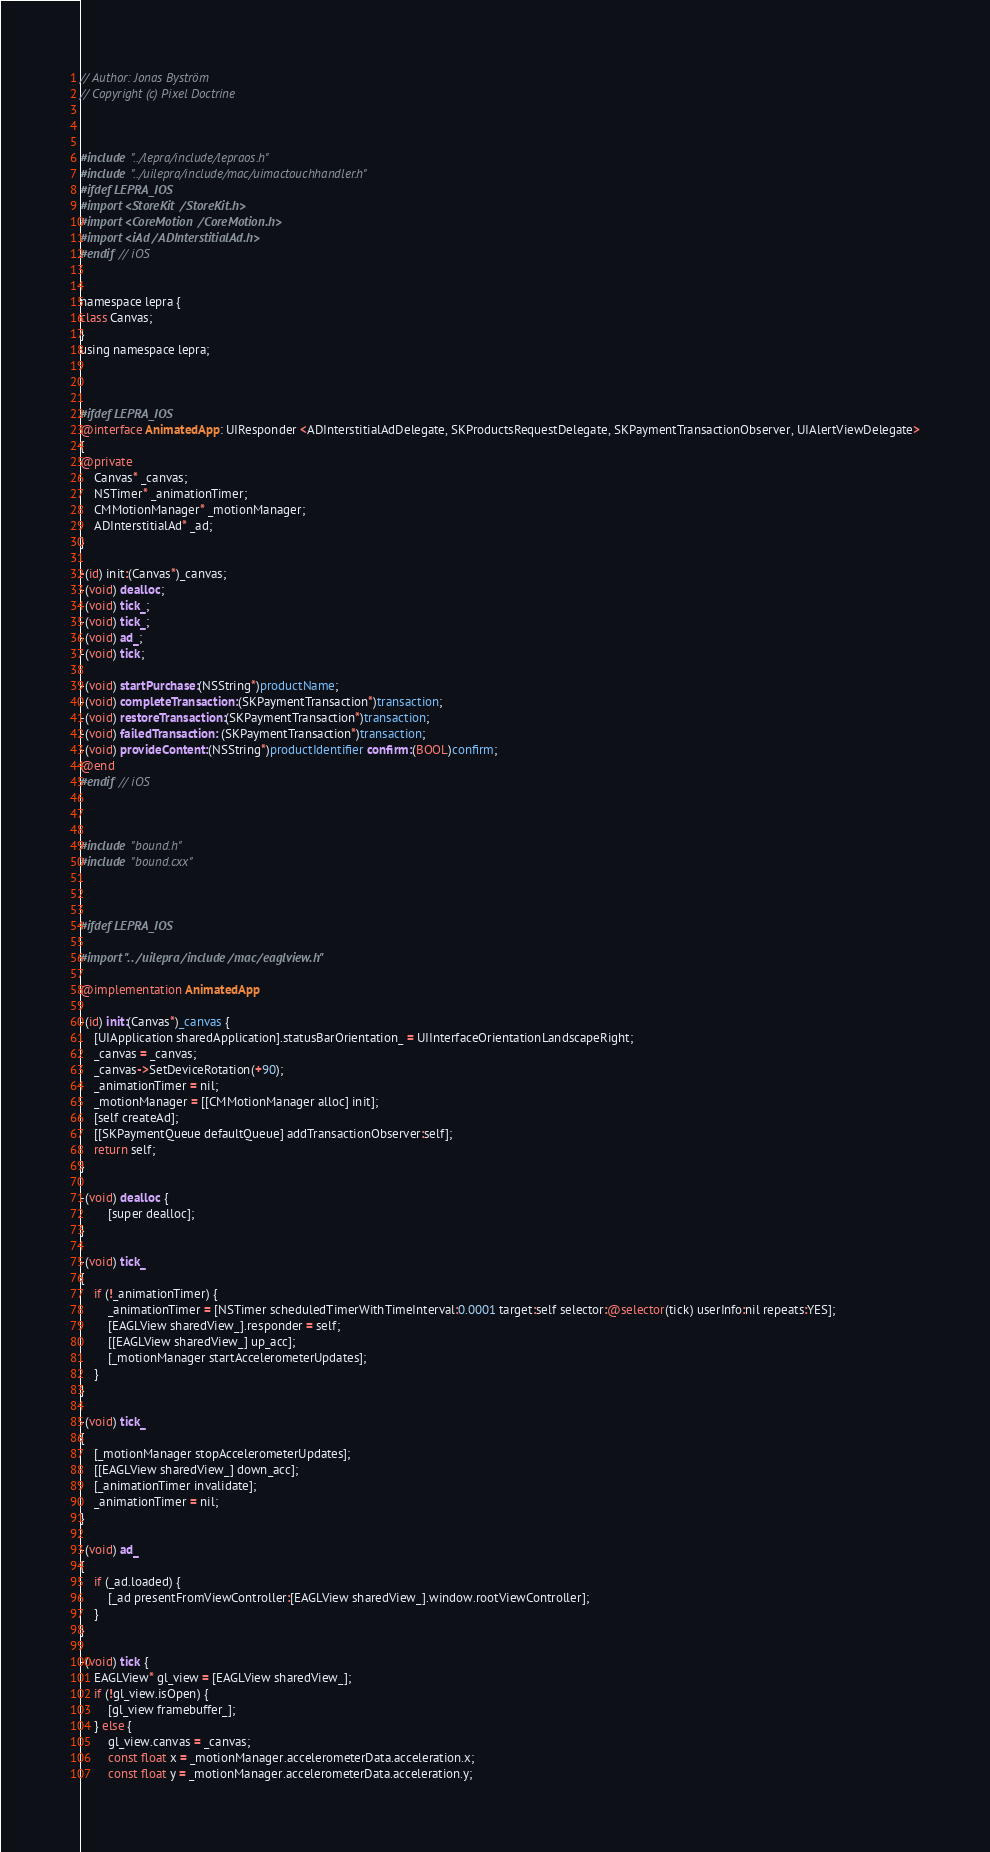Convert code to text. <code><loc_0><loc_0><loc_500><loc_500><_ObjectiveC_>
// Author: Jonas Byström
// Copyright (c) Pixel Doctrine



#include "../lepra/include/lepraos.h"
#include "../uilepra/include/mac/uimactouchhandler.h"
#ifdef LEPRA_IOS
#import <StoreKit/StoreKit.h>
#import <CoreMotion/CoreMotion.h>
#import <iAd/ADInterstitialAd.h>
#endif // iOS


namespace lepra {
class Canvas;
}
using namespace lepra;



#ifdef LEPRA_IOS
@interface AnimatedApp: UIResponder <ADInterstitialAdDelegate, SKProductsRequestDelegate, SKPaymentTransactionObserver, UIAlertViewDelegate>
{
@private
	Canvas* _canvas;
	NSTimer* _animationTimer;
	CMMotionManager* _motionManager;
	ADInterstitialAd* _ad;
}

-(id) init:(Canvas*)_canvas;
-(void) dealloc;
-(void) tick_;
-(void) tick_;
-(void) ad_;
-(void) tick;

-(void) startPurchase:(NSString*)productName;
-(void) completeTransaction:(SKPaymentTransaction*)transaction;
-(void) restoreTransaction:(SKPaymentTransaction*)transaction;
-(void) failedTransaction: (SKPaymentTransaction*)transaction;
-(void) provideContent:(NSString*)productIdentifier confirm:(BOOL)confirm;
@end
#endif // iOS



#include "bound.h"
#include "bound.cxx"



#ifdef LEPRA_IOS

#import "../uilepra/include/mac/eaglview.h"

@implementation AnimatedApp

-(id) init:(Canvas*)_canvas {
	[UIApplication sharedApplication].statusBarOrientation_ = UIInterfaceOrientationLandscapeRight;
	_canvas = _canvas;
	_canvas->SetDeviceRotation(+90);
	_animationTimer = nil;
	_motionManager = [[CMMotionManager alloc] init];
	[self createAd];
	[[SKPaymentQueue defaultQueue] addTransactionObserver:self];
	return self;
}

-(void) dealloc {
        [super dealloc];
}

-(void) tick_
{
	if (!_animationTimer) {
		_animationTimer = [NSTimer scheduledTimerWithTimeInterval:0.0001 target:self selector:@selector(tick) userInfo:nil repeats:YES];
		[EAGLView sharedView_].responder = self;
		[[EAGLView sharedView_] up_acc];
		[_motionManager startAccelerometerUpdates];
	}
}

-(void) tick_
{
	[_motionManager stopAccelerometerUpdates];
	[[EAGLView sharedView_] down_acc];
	[_animationTimer invalidate];
	_animationTimer = nil;
}

-(void) ad_
{
	if (_ad.loaded) {
		[_ad presentFromViewController:[EAGLView sharedView_].window.rootViewController];
	}
}

-(void) tick {
	EAGLView* gl_view = [EAGLView sharedView_];
	if (!gl_view.isOpen) {
		[gl_view framebuffer_];
	} else {
		gl_view.canvas = _canvas;
		const float x = _motionManager.accelerometerData.acceleration.x;
		const float y = _motionManager.accelerometerData.acceleration.y;</code> 